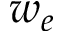<formula> <loc_0><loc_0><loc_500><loc_500>w _ { e }</formula> 